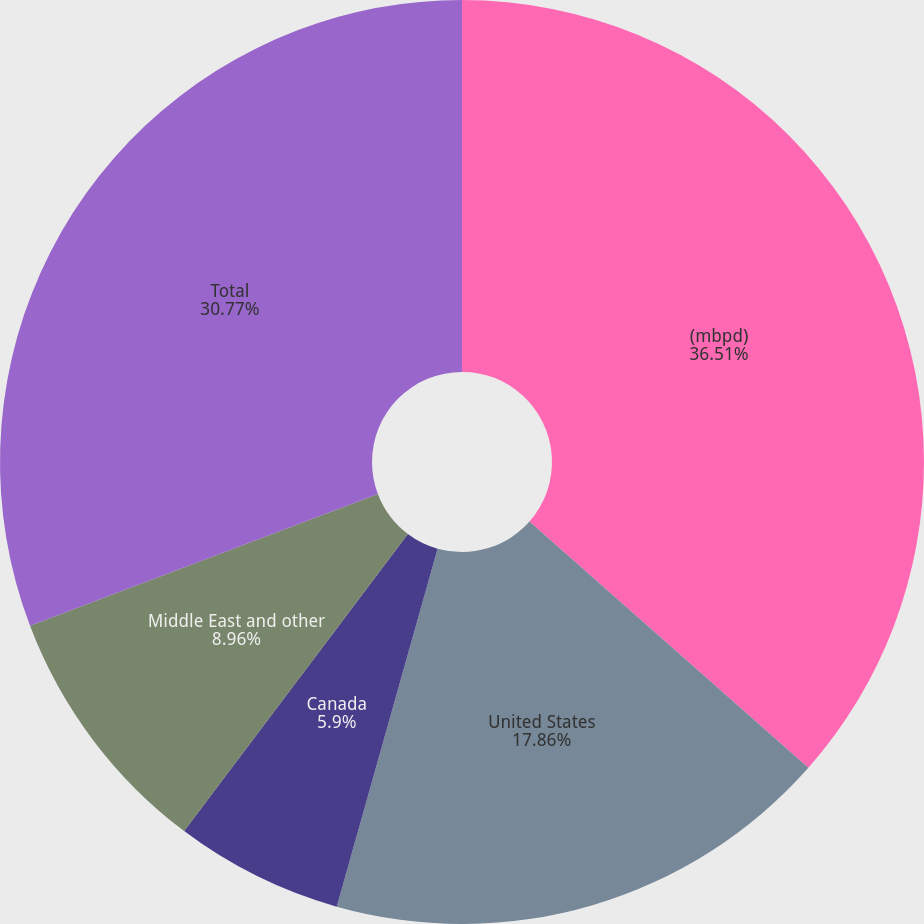Convert chart to OTSL. <chart><loc_0><loc_0><loc_500><loc_500><pie_chart><fcel>(mbpd)<fcel>United States<fcel>Canada<fcel>Middle East and other<fcel>Total<nl><fcel>36.51%<fcel>17.86%<fcel>5.9%<fcel>8.96%<fcel>30.77%<nl></chart> 